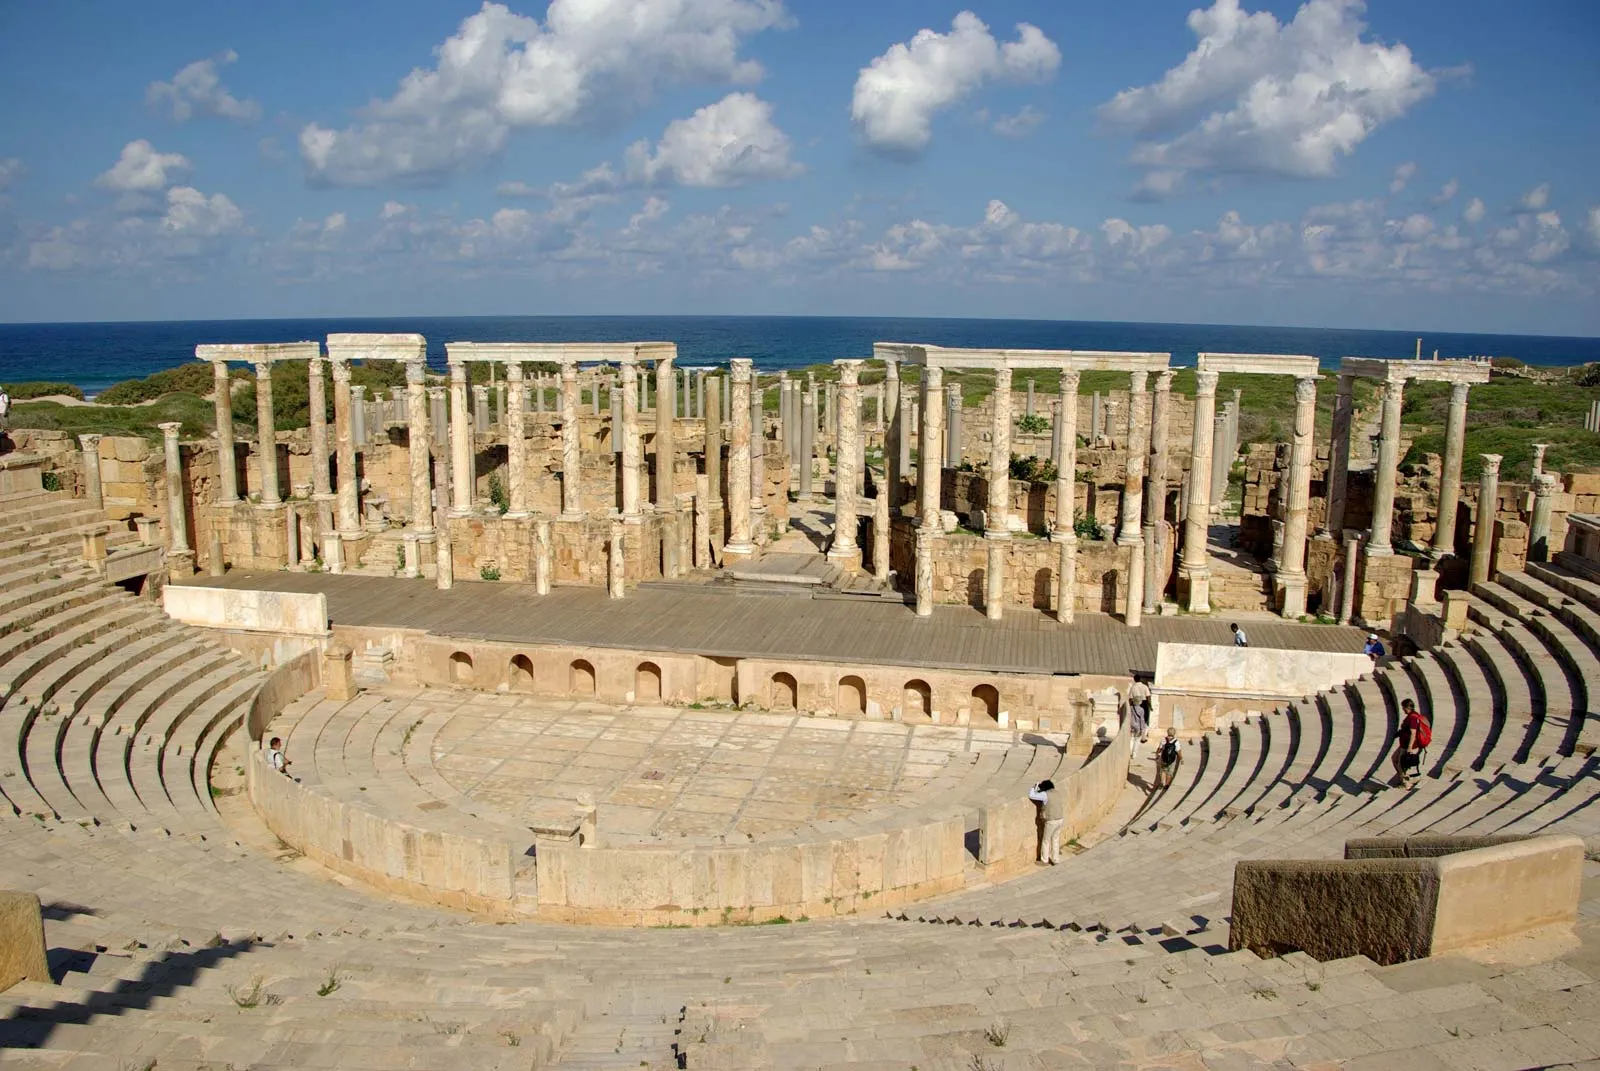Imagine you lived in the ancient Roman era. How might a day in this amphitheater unfold? If you were transported back to the ancient Roman era, a day at the Leptis Magna amphitheater might begin with the hustle and bustle of townspeople gathering early in the morning. As the sun rises, the streets would be filled with vendors selling refreshments and trinkets. You'd find yourself among senators, merchants, and common citizens, all eagerly moving towards the amphitheater. Once inside, the noise and energy would be palpable as you take your seat among the stone tiers. Trumpets would sound, signaling the start of the day’s events. Gladiators would enter the arena, the crowd roaring with anticipation. The air would be thick with excitement as the combatants face off in a display of skill and bravery. Later in the day, perhaps dramatic performances or even religious ceremonies might take place, each event showcasing the rich cultural fabric of Roman society. 